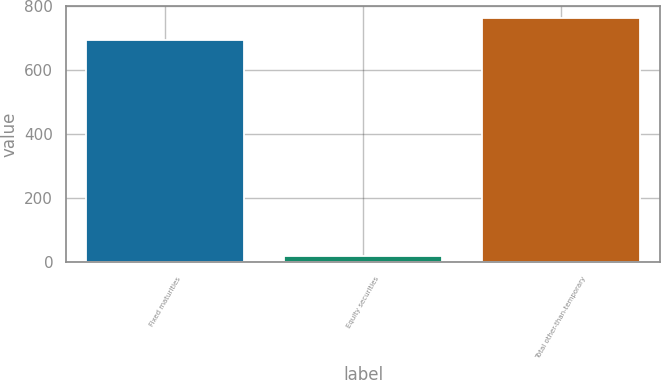<chart> <loc_0><loc_0><loc_500><loc_500><bar_chart><fcel>Fixed maturities<fcel>Equity securities<fcel>Total other-than-temporary<nl><fcel>693.6<fcel>20.5<fcel>762.96<nl></chart> 